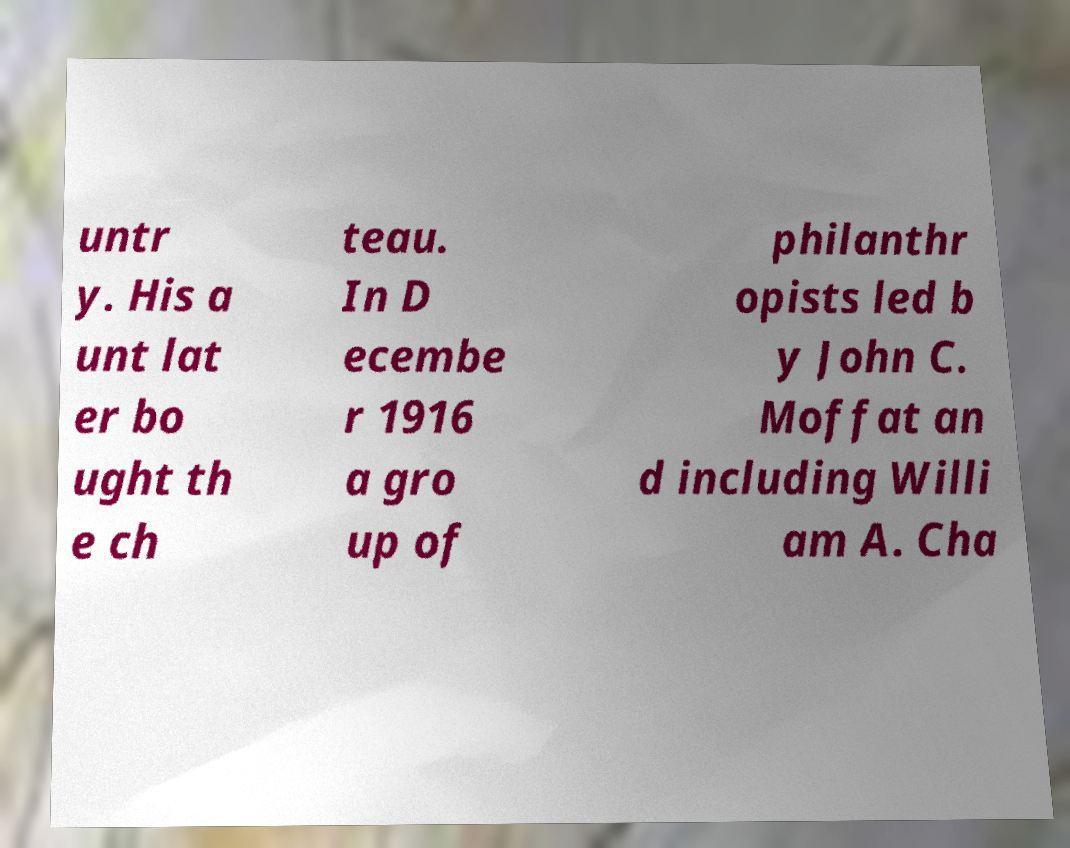What messages or text are displayed in this image? I need them in a readable, typed format. untr y. His a unt lat er bo ught th e ch teau. In D ecembe r 1916 a gro up of philanthr opists led b y John C. Moffat an d including Willi am A. Cha 